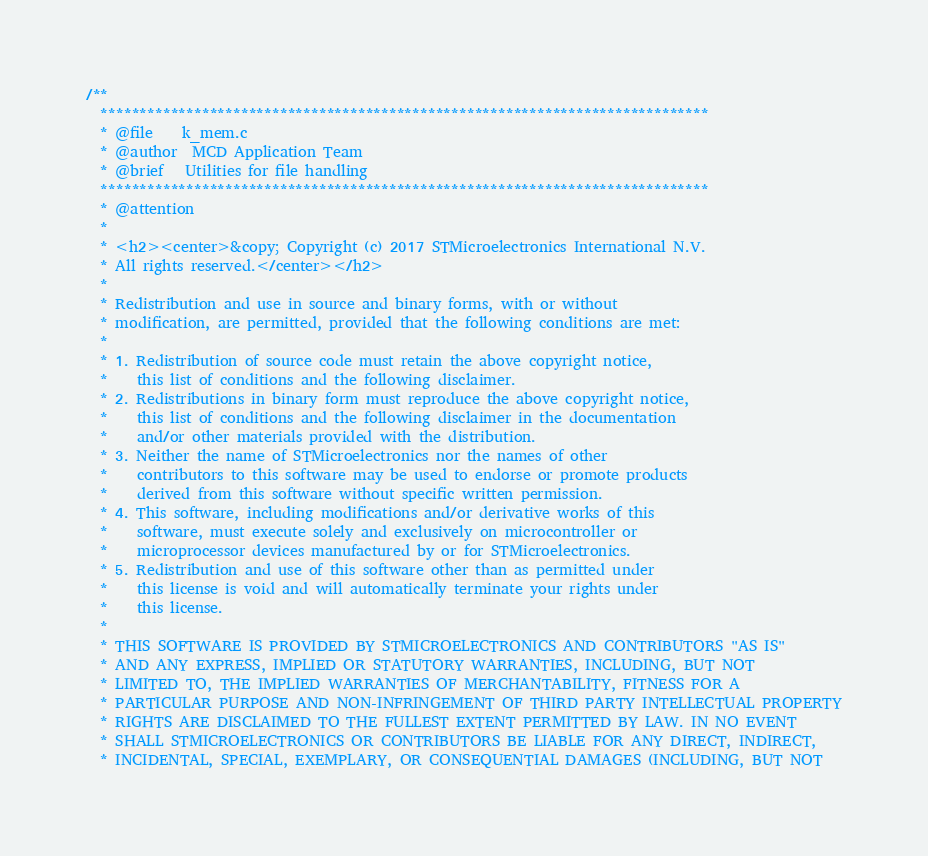Convert code to text. <code><loc_0><loc_0><loc_500><loc_500><_C_>/**
  ******************************************************************************
  * @file    k_mem.c
  * @author  MCD Application Team
  * @brief   Utilities for file handling
  ******************************************************************************
  * @attention
  *
  * <h2><center>&copy; Copyright (c) 2017 STMicroelectronics International N.V. 
  * All rights reserved.</center></h2>
  *
  * Redistribution and use in source and binary forms, with or without 
  * modification, are permitted, provided that the following conditions are met:
  *
  * 1. Redistribution of source code must retain the above copyright notice, 
  *    this list of conditions and the following disclaimer.
  * 2. Redistributions in binary form must reproduce the above copyright notice,
  *    this list of conditions and the following disclaimer in the documentation
  *    and/or other materials provided with the distribution.
  * 3. Neither the name of STMicroelectronics nor the names of other 
  *    contributors to this software may be used to endorse or promote products 
  *    derived from this software without specific written permission.
  * 4. This software, including modifications and/or derivative works of this 
  *    software, must execute solely and exclusively on microcontroller or
  *    microprocessor devices manufactured by or for STMicroelectronics.
  * 5. Redistribution and use of this software other than as permitted under 
  *    this license is void and will automatically terminate your rights under 
  *    this license. 
  *
  * THIS SOFTWARE IS PROVIDED BY STMICROELECTRONICS AND CONTRIBUTORS "AS IS" 
  * AND ANY EXPRESS, IMPLIED OR STATUTORY WARRANTIES, INCLUDING, BUT NOT 
  * LIMITED TO, THE IMPLIED WARRANTIES OF MERCHANTABILITY, FITNESS FOR A 
  * PARTICULAR PURPOSE AND NON-INFRINGEMENT OF THIRD PARTY INTELLECTUAL PROPERTY
  * RIGHTS ARE DISCLAIMED TO THE FULLEST EXTENT PERMITTED BY LAW. IN NO EVENT 
  * SHALL STMICROELECTRONICS OR CONTRIBUTORS BE LIABLE FOR ANY DIRECT, INDIRECT,
  * INCIDENTAL, SPECIAL, EXEMPLARY, OR CONSEQUENTIAL DAMAGES (INCLUDING, BUT NOT</code> 